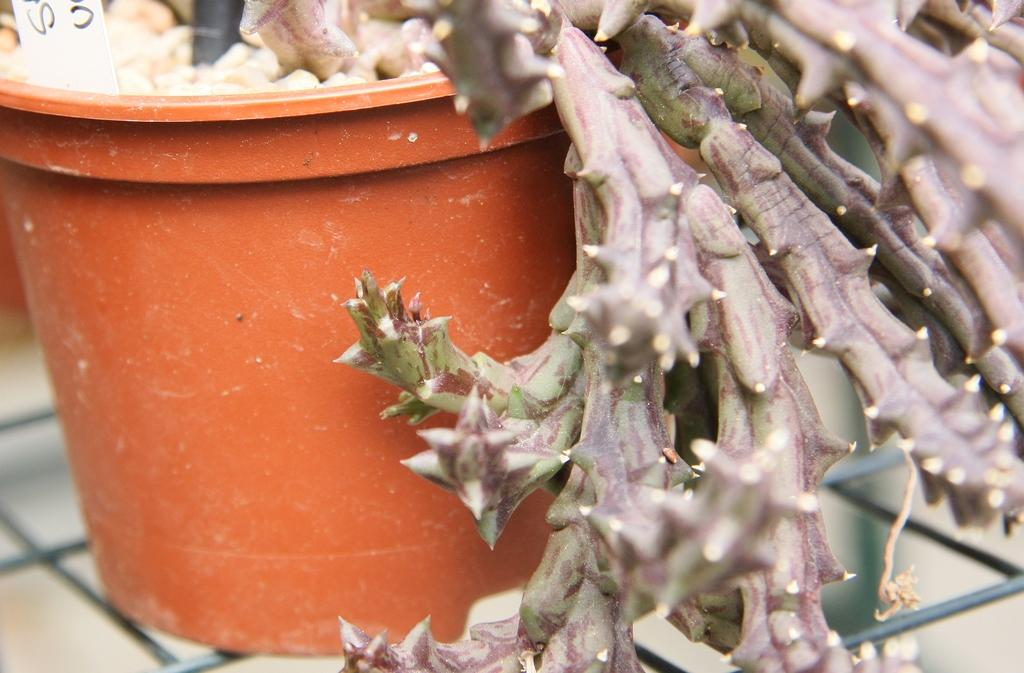What object is present in the image that contains a plant? There is a flower pot in the image that contains a plant. What is located beneath the flower pot? There is a grill under the flower pot. What effect does the shock have on the plant in the image? There is no mention of a shock or any electrical component in the image, so it is not possible to determine any effect on the plant. 